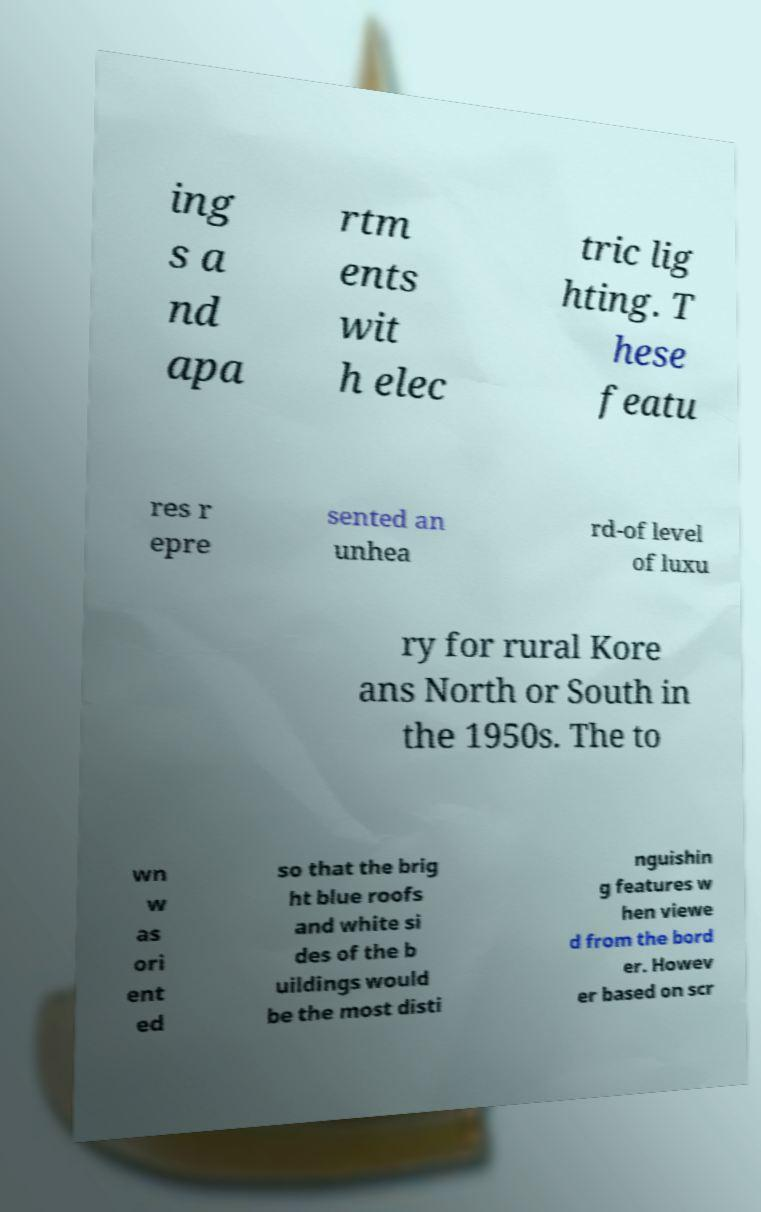For documentation purposes, I need the text within this image transcribed. Could you provide that? ing s a nd apa rtm ents wit h elec tric lig hting. T hese featu res r epre sented an unhea rd-of level of luxu ry for rural Kore ans North or South in the 1950s. The to wn w as ori ent ed so that the brig ht blue roofs and white si des of the b uildings would be the most disti nguishin g features w hen viewe d from the bord er. Howev er based on scr 